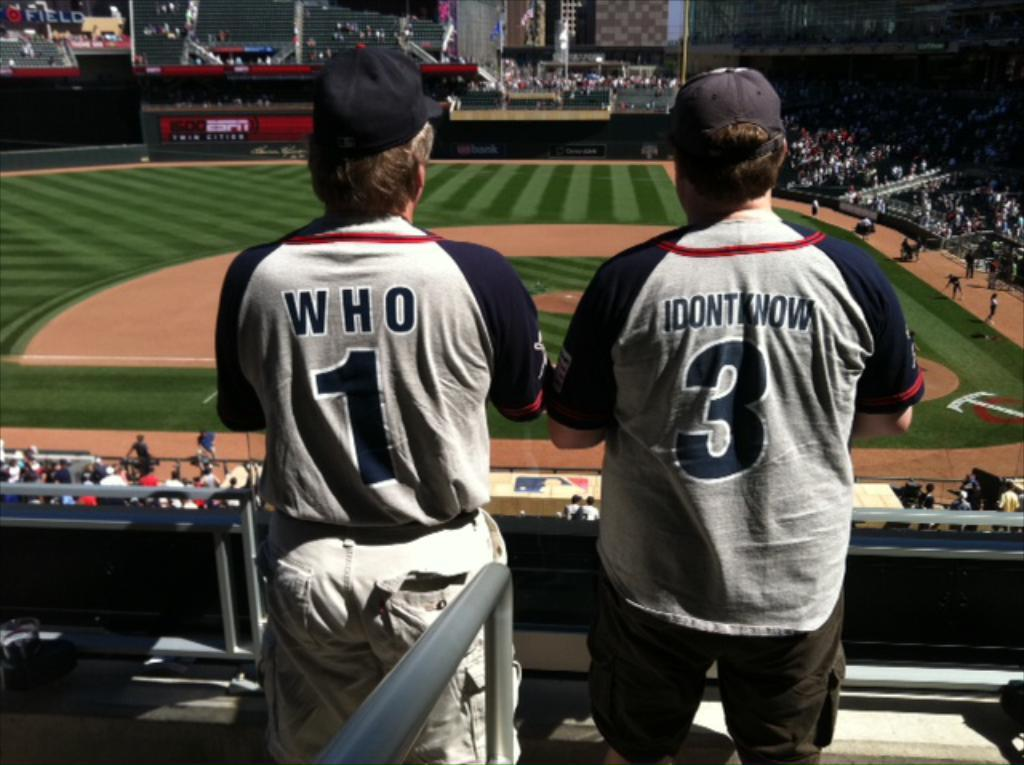<image>
Provide a brief description of the given image. Two fans at a baseball game wearing the numbers 1 and 3. 